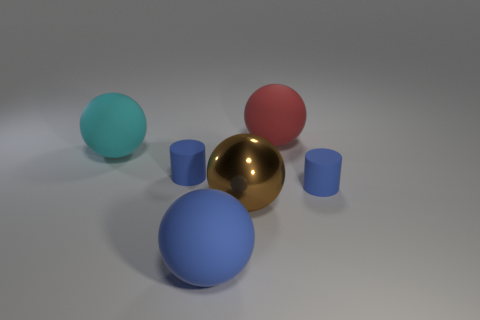Subtract all big cyan rubber spheres. How many spheres are left? 3 Add 1 large cyan matte things. How many objects exist? 7 Subtract 2 balls. How many balls are left? 2 Subtract all blue balls. How many balls are left? 3 Add 6 tiny cylinders. How many tiny cylinders exist? 8 Subtract 0 gray spheres. How many objects are left? 6 Subtract all spheres. How many objects are left? 2 Subtract all red spheres. Subtract all cyan cubes. How many spheres are left? 3 Subtract all red things. Subtract all tiny green metallic spheres. How many objects are left? 5 Add 2 cylinders. How many cylinders are left? 4 